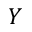Convert formula to latex. <formula><loc_0><loc_0><loc_500><loc_500>Y</formula> 